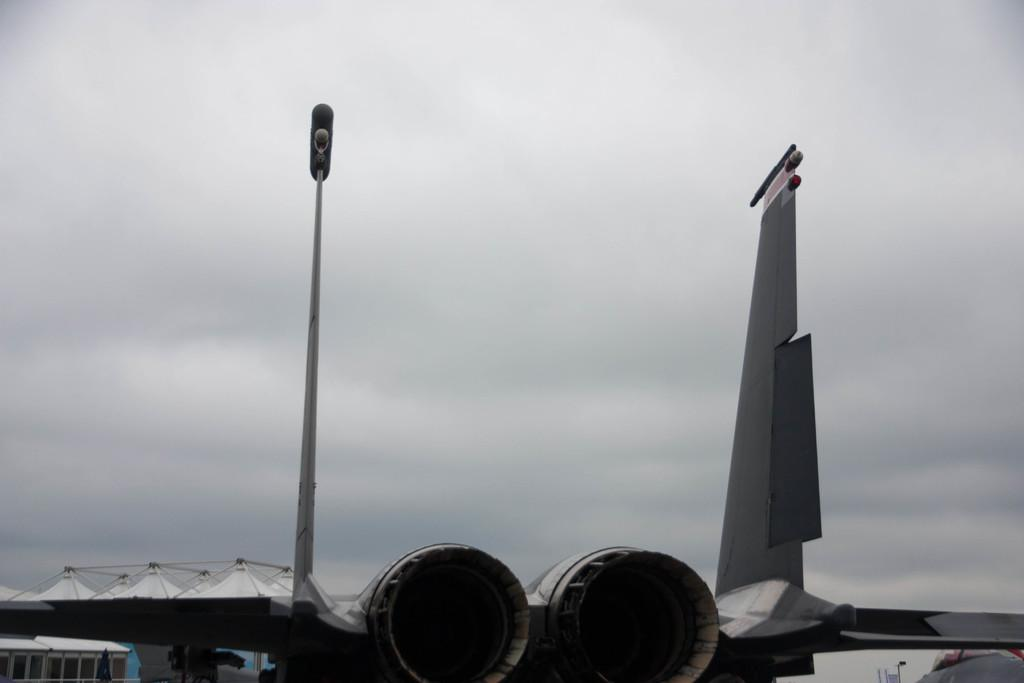What is the main subject in the foreground of the image? There is an aircraft in the foreground of the image. What can be seen on the left side of the image? There are buildings on the left side of the image. What is visible at the top of the image? The sky is visible at the top of the image. How would you describe the sky in the image? The sky is cloudy in the image. How many apples are hanging from the aircraft in the image? There are no apples present in the image, and therefore none are hanging from the aircraft. 